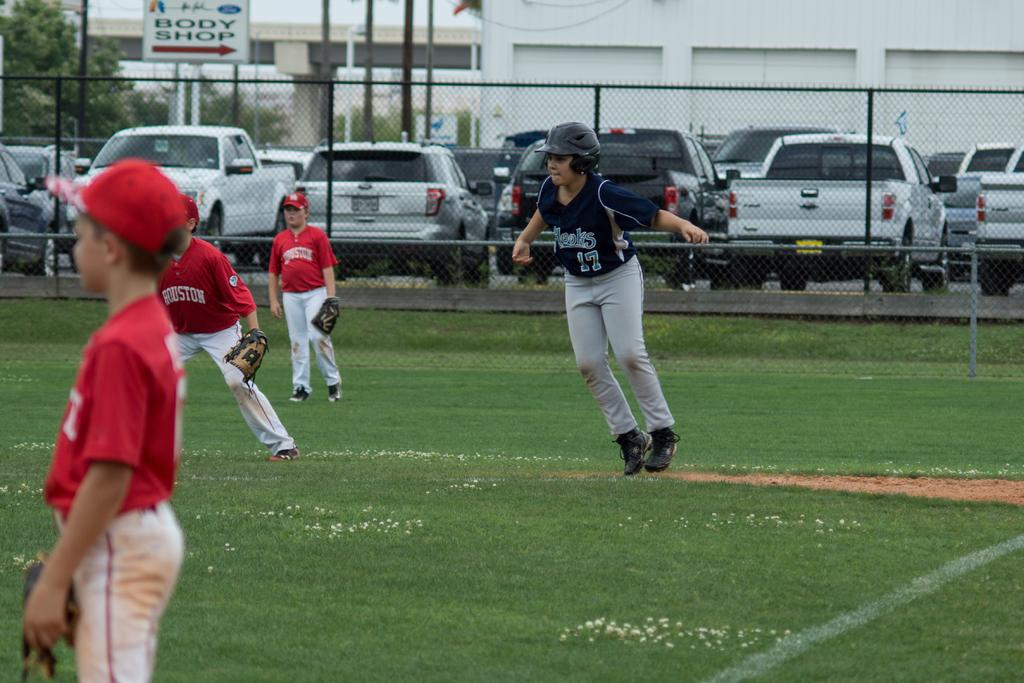<image>
Give a short and clear explanation of the subsequent image. the number 17 is on the black jersey 